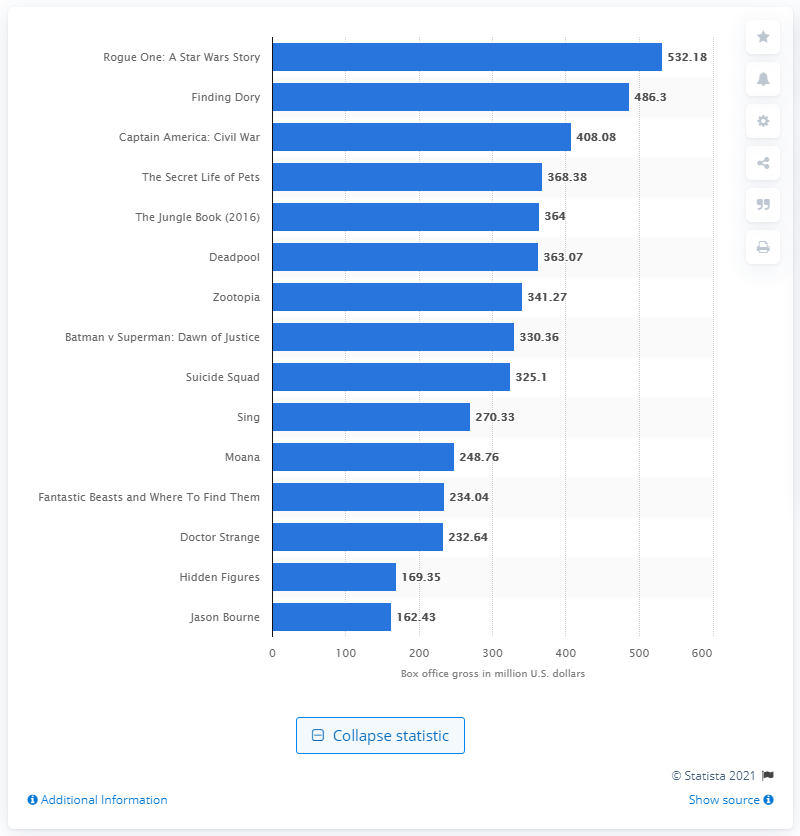Identify some key points in this picture. The domestic box office revenue of "Rogue One: A Star Wars Story" was $532.18 million. 